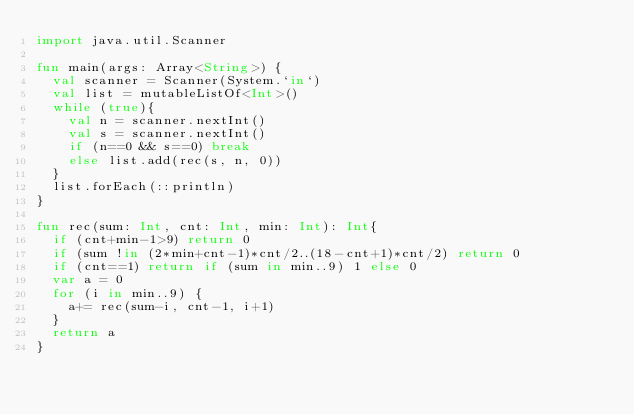Convert code to text. <code><loc_0><loc_0><loc_500><loc_500><_Kotlin_>import java.util.Scanner

fun main(args: Array<String>) {
	val scanner = Scanner(System.`in`)
	val list = mutableListOf<Int>()
	while (true){
		val n = scanner.nextInt()
		val s = scanner.nextInt()
		if (n==0 && s==0) break
		else list.add(rec(s, n, 0))
	}
	list.forEach(::println)
}

fun rec(sum: Int, cnt: Int, min: Int): Int{
	if (cnt+min-1>9) return 0
	if (sum !in (2*min+cnt-1)*cnt/2..(18-cnt+1)*cnt/2) return 0
	if (cnt==1) return if (sum in min..9) 1 else 0
	var a = 0
	for (i in min..9) {
		a+= rec(sum-i, cnt-1, i+1)
	}
	return a
}
</code> 